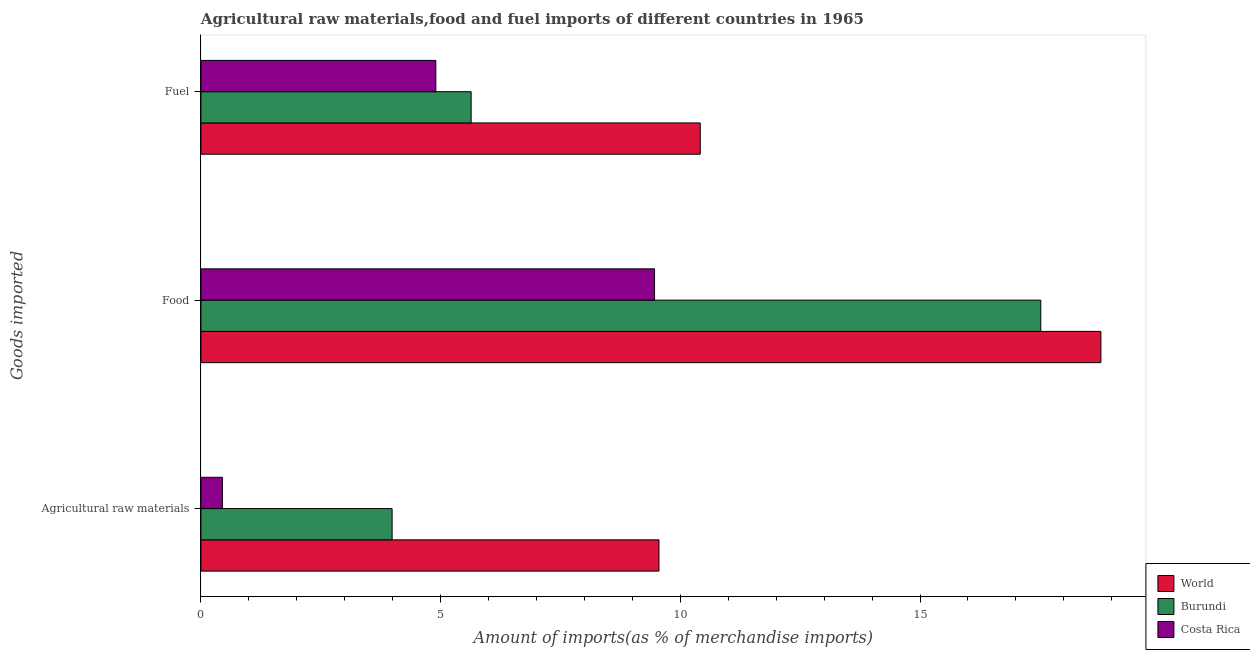How many different coloured bars are there?
Keep it short and to the point. 3. Are the number of bars per tick equal to the number of legend labels?
Your response must be concise. Yes. Are the number of bars on each tick of the Y-axis equal?
Provide a succinct answer. Yes. How many bars are there on the 3rd tick from the top?
Your answer should be compact. 3. What is the label of the 2nd group of bars from the top?
Keep it short and to the point. Food. What is the percentage of fuel imports in World?
Your answer should be very brief. 10.42. Across all countries, what is the maximum percentage of food imports?
Your answer should be compact. 18.77. Across all countries, what is the minimum percentage of fuel imports?
Ensure brevity in your answer.  4.9. In which country was the percentage of fuel imports maximum?
Ensure brevity in your answer.  World. In which country was the percentage of raw materials imports minimum?
Your response must be concise. Costa Rica. What is the total percentage of food imports in the graph?
Keep it short and to the point. 45.76. What is the difference between the percentage of raw materials imports in Costa Rica and that in World?
Make the answer very short. -9.11. What is the difference between the percentage of food imports in Costa Rica and the percentage of raw materials imports in World?
Your response must be concise. -0.09. What is the average percentage of food imports per country?
Give a very brief answer. 15.25. What is the difference between the percentage of fuel imports and percentage of food imports in Costa Rica?
Offer a terse response. -4.56. In how many countries, is the percentage of raw materials imports greater than 11 %?
Your response must be concise. 0. What is the ratio of the percentage of fuel imports in Costa Rica to that in World?
Offer a very short reply. 0.47. What is the difference between the highest and the second highest percentage of food imports?
Keep it short and to the point. 1.25. What is the difference between the highest and the lowest percentage of fuel imports?
Your answer should be compact. 5.52. In how many countries, is the percentage of food imports greater than the average percentage of food imports taken over all countries?
Your answer should be very brief. 2. Is the sum of the percentage of raw materials imports in World and Burundi greater than the maximum percentage of fuel imports across all countries?
Provide a succinct answer. Yes. What does the 1st bar from the bottom in Agricultural raw materials represents?
Ensure brevity in your answer.  World. Is it the case that in every country, the sum of the percentage of raw materials imports and percentage of food imports is greater than the percentage of fuel imports?
Give a very brief answer. Yes. How many bars are there?
Keep it short and to the point. 9. Are all the bars in the graph horizontal?
Ensure brevity in your answer.  Yes. Are the values on the major ticks of X-axis written in scientific E-notation?
Ensure brevity in your answer.  No. Does the graph contain grids?
Offer a very short reply. No. Where does the legend appear in the graph?
Ensure brevity in your answer.  Bottom right. How many legend labels are there?
Make the answer very short. 3. How are the legend labels stacked?
Make the answer very short. Vertical. What is the title of the graph?
Offer a very short reply. Agricultural raw materials,food and fuel imports of different countries in 1965. What is the label or title of the X-axis?
Provide a succinct answer. Amount of imports(as % of merchandise imports). What is the label or title of the Y-axis?
Offer a very short reply. Goods imported. What is the Amount of imports(as % of merchandise imports) in World in Agricultural raw materials?
Give a very brief answer. 9.56. What is the Amount of imports(as % of merchandise imports) in Burundi in Agricultural raw materials?
Provide a succinct answer. 3.99. What is the Amount of imports(as % of merchandise imports) in Costa Rica in Agricultural raw materials?
Make the answer very short. 0.45. What is the Amount of imports(as % of merchandise imports) in World in Food?
Your response must be concise. 18.77. What is the Amount of imports(as % of merchandise imports) in Burundi in Food?
Give a very brief answer. 17.52. What is the Amount of imports(as % of merchandise imports) in Costa Rica in Food?
Offer a very short reply. 9.46. What is the Amount of imports(as % of merchandise imports) in World in Fuel?
Keep it short and to the point. 10.42. What is the Amount of imports(as % of merchandise imports) in Burundi in Fuel?
Make the answer very short. 5.64. What is the Amount of imports(as % of merchandise imports) of Costa Rica in Fuel?
Give a very brief answer. 4.9. Across all Goods imported, what is the maximum Amount of imports(as % of merchandise imports) of World?
Your response must be concise. 18.77. Across all Goods imported, what is the maximum Amount of imports(as % of merchandise imports) of Burundi?
Your response must be concise. 17.52. Across all Goods imported, what is the maximum Amount of imports(as % of merchandise imports) of Costa Rica?
Your answer should be compact. 9.46. Across all Goods imported, what is the minimum Amount of imports(as % of merchandise imports) in World?
Your answer should be compact. 9.56. Across all Goods imported, what is the minimum Amount of imports(as % of merchandise imports) in Burundi?
Provide a short and direct response. 3.99. Across all Goods imported, what is the minimum Amount of imports(as % of merchandise imports) of Costa Rica?
Keep it short and to the point. 0.45. What is the total Amount of imports(as % of merchandise imports) of World in the graph?
Make the answer very short. 38.74. What is the total Amount of imports(as % of merchandise imports) of Burundi in the graph?
Your response must be concise. 27.14. What is the total Amount of imports(as % of merchandise imports) in Costa Rica in the graph?
Your answer should be compact. 14.81. What is the difference between the Amount of imports(as % of merchandise imports) of World in Agricultural raw materials and that in Food?
Your answer should be very brief. -9.22. What is the difference between the Amount of imports(as % of merchandise imports) in Burundi in Agricultural raw materials and that in Food?
Your answer should be very brief. -13.53. What is the difference between the Amount of imports(as % of merchandise imports) of Costa Rica in Agricultural raw materials and that in Food?
Keep it short and to the point. -9.02. What is the difference between the Amount of imports(as % of merchandise imports) in World in Agricultural raw materials and that in Fuel?
Offer a very short reply. -0.86. What is the difference between the Amount of imports(as % of merchandise imports) of Burundi in Agricultural raw materials and that in Fuel?
Make the answer very short. -1.65. What is the difference between the Amount of imports(as % of merchandise imports) of Costa Rica in Agricultural raw materials and that in Fuel?
Your answer should be compact. -4.45. What is the difference between the Amount of imports(as % of merchandise imports) of World in Food and that in Fuel?
Give a very brief answer. 8.36. What is the difference between the Amount of imports(as % of merchandise imports) in Burundi in Food and that in Fuel?
Your answer should be very brief. 11.88. What is the difference between the Amount of imports(as % of merchandise imports) in Costa Rica in Food and that in Fuel?
Your answer should be very brief. 4.56. What is the difference between the Amount of imports(as % of merchandise imports) of World in Agricultural raw materials and the Amount of imports(as % of merchandise imports) of Burundi in Food?
Keep it short and to the point. -7.96. What is the difference between the Amount of imports(as % of merchandise imports) in World in Agricultural raw materials and the Amount of imports(as % of merchandise imports) in Costa Rica in Food?
Provide a succinct answer. 0.09. What is the difference between the Amount of imports(as % of merchandise imports) in Burundi in Agricultural raw materials and the Amount of imports(as % of merchandise imports) in Costa Rica in Food?
Keep it short and to the point. -5.47. What is the difference between the Amount of imports(as % of merchandise imports) of World in Agricultural raw materials and the Amount of imports(as % of merchandise imports) of Burundi in Fuel?
Provide a succinct answer. 3.92. What is the difference between the Amount of imports(as % of merchandise imports) of World in Agricultural raw materials and the Amount of imports(as % of merchandise imports) of Costa Rica in Fuel?
Give a very brief answer. 4.66. What is the difference between the Amount of imports(as % of merchandise imports) in Burundi in Agricultural raw materials and the Amount of imports(as % of merchandise imports) in Costa Rica in Fuel?
Make the answer very short. -0.91. What is the difference between the Amount of imports(as % of merchandise imports) in World in Food and the Amount of imports(as % of merchandise imports) in Burundi in Fuel?
Offer a terse response. 13.14. What is the difference between the Amount of imports(as % of merchandise imports) in World in Food and the Amount of imports(as % of merchandise imports) in Costa Rica in Fuel?
Offer a terse response. 13.87. What is the difference between the Amount of imports(as % of merchandise imports) in Burundi in Food and the Amount of imports(as % of merchandise imports) in Costa Rica in Fuel?
Keep it short and to the point. 12.62. What is the average Amount of imports(as % of merchandise imports) of World per Goods imported?
Ensure brevity in your answer.  12.91. What is the average Amount of imports(as % of merchandise imports) of Burundi per Goods imported?
Keep it short and to the point. 9.05. What is the average Amount of imports(as % of merchandise imports) of Costa Rica per Goods imported?
Your answer should be very brief. 4.94. What is the difference between the Amount of imports(as % of merchandise imports) of World and Amount of imports(as % of merchandise imports) of Burundi in Agricultural raw materials?
Your response must be concise. 5.57. What is the difference between the Amount of imports(as % of merchandise imports) of World and Amount of imports(as % of merchandise imports) of Costa Rica in Agricultural raw materials?
Give a very brief answer. 9.11. What is the difference between the Amount of imports(as % of merchandise imports) in Burundi and Amount of imports(as % of merchandise imports) in Costa Rica in Agricultural raw materials?
Offer a very short reply. 3.54. What is the difference between the Amount of imports(as % of merchandise imports) in World and Amount of imports(as % of merchandise imports) in Burundi in Food?
Provide a short and direct response. 1.25. What is the difference between the Amount of imports(as % of merchandise imports) of World and Amount of imports(as % of merchandise imports) of Costa Rica in Food?
Make the answer very short. 9.31. What is the difference between the Amount of imports(as % of merchandise imports) of Burundi and Amount of imports(as % of merchandise imports) of Costa Rica in Food?
Provide a succinct answer. 8.06. What is the difference between the Amount of imports(as % of merchandise imports) in World and Amount of imports(as % of merchandise imports) in Burundi in Fuel?
Offer a very short reply. 4.78. What is the difference between the Amount of imports(as % of merchandise imports) in World and Amount of imports(as % of merchandise imports) in Costa Rica in Fuel?
Offer a very short reply. 5.52. What is the difference between the Amount of imports(as % of merchandise imports) of Burundi and Amount of imports(as % of merchandise imports) of Costa Rica in Fuel?
Offer a terse response. 0.74. What is the ratio of the Amount of imports(as % of merchandise imports) in World in Agricultural raw materials to that in Food?
Offer a terse response. 0.51. What is the ratio of the Amount of imports(as % of merchandise imports) in Burundi in Agricultural raw materials to that in Food?
Keep it short and to the point. 0.23. What is the ratio of the Amount of imports(as % of merchandise imports) of Costa Rica in Agricultural raw materials to that in Food?
Give a very brief answer. 0.05. What is the ratio of the Amount of imports(as % of merchandise imports) in World in Agricultural raw materials to that in Fuel?
Keep it short and to the point. 0.92. What is the ratio of the Amount of imports(as % of merchandise imports) in Burundi in Agricultural raw materials to that in Fuel?
Provide a succinct answer. 0.71. What is the ratio of the Amount of imports(as % of merchandise imports) of Costa Rica in Agricultural raw materials to that in Fuel?
Your answer should be very brief. 0.09. What is the ratio of the Amount of imports(as % of merchandise imports) of World in Food to that in Fuel?
Keep it short and to the point. 1.8. What is the ratio of the Amount of imports(as % of merchandise imports) in Burundi in Food to that in Fuel?
Your response must be concise. 3.11. What is the ratio of the Amount of imports(as % of merchandise imports) of Costa Rica in Food to that in Fuel?
Your answer should be very brief. 1.93. What is the difference between the highest and the second highest Amount of imports(as % of merchandise imports) of World?
Ensure brevity in your answer.  8.36. What is the difference between the highest and the second highest Amount of imports(as % of merchandise imports) in Burundi?
Provide a succinct answer. 11.88. What is the difference between the highest and the second highest Amount of imports(as % of merchandise imports) of Costa Rica?
Your response must be concise. 4.56. What is the difference between the highest and the lowest Amount of imports(as % of merchandise imports) of World?
Keep it short and to the point. 9.22. What is the difference between the highest and the lowest Amount of imports(as % of merchandise imports) of Burundi?
Ensure brevity in your answer.  13.53. What is the difference between the highest and the lowest Amount of imports(as % of merchandise imports) in Costa Rica?
Provide a succinct answer. 9.02. 